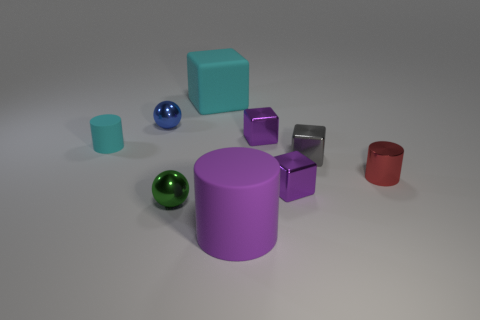There is a matte thing that is the same color as the big cube; what is its shape?
Keep it short and to the point. Cylinder. Do the metallic thing that is on the left side of the small green shiny ball and the big matte object that is left of the large purple rubber cylinder have the same shape?
Ensure brevity in your answer.  No. What is the material of the cyan thing that is the same shape as the red thing?
Provide a short and direct response. Rubber. What color is the small object that is both behind the cyan rubber cylinder and right of the big purple matte object?
Provide a short and direct response. Purple. Are there any metal cubes that are on the right side of the small purple object in front of the metallic cylinder on the right side of the large cyan matte block?
Give a very brief answer. Yes. How many objects are large purple matte objects or rubber objects?
Make the answer very short. 3. Is the material of the red cylinder the same as the cylinder that is in front of the small green metallic object?
Ensure brevity in your answer.  No. Are there any other things that have the same color as the metal cylinder?
Offer a very short reply. No. How many things are either spheres in front of the gray metallic object or metallic things that are on the right side of the small blue shiny object?
Offer a terse response. 5. What shape is the small metal thing that is both behind the small cyan object and on the right side of the large cube?
Give a very brief answer. Cube. 